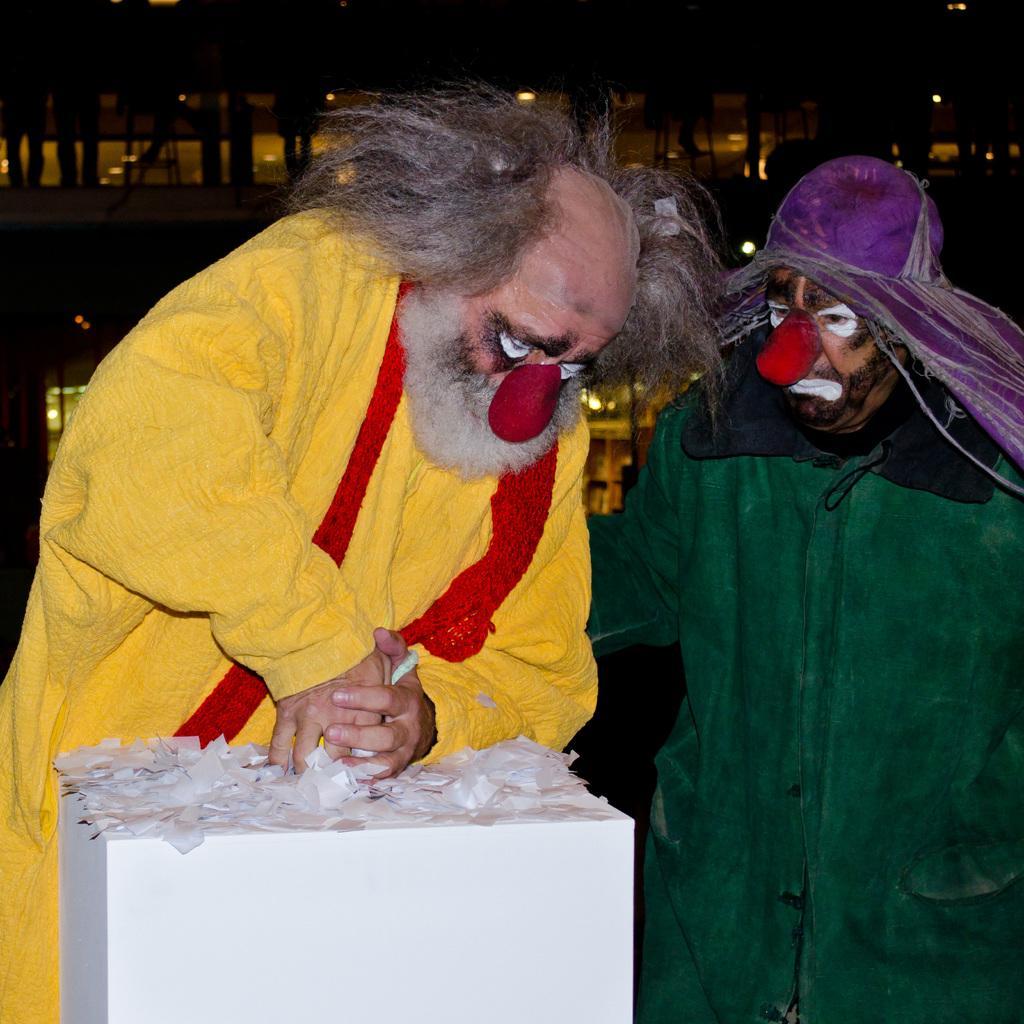Please provide a concise description of this image. In this image in the center there are two persons standing and in the background there is a building. In the front there is a white box and the person standing behind the box is wearing a yellow colour dress. 